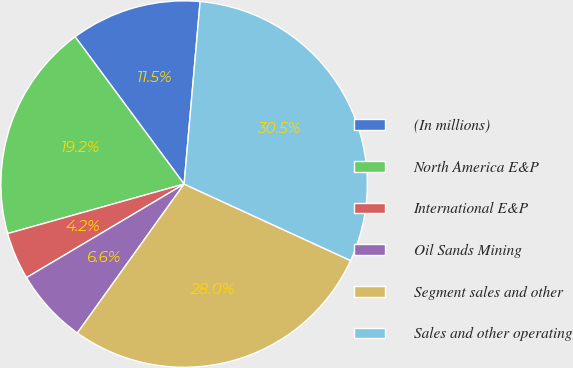<chart> <loc_0><loc_0><loc_500><loc_500><pie_chart><fcel>(In millions)<fcel>North America E&P<fcel>International E&P<fcel>Oil Sands Mining<fcel>Segment sales and other<fcel>Sales and other operating<nl><fcel>11.53%<fcel>19.22%<fcel>4.17%<fcel>6.58%<fcel>28.04%<fcel>30.46%<nl></chart> 